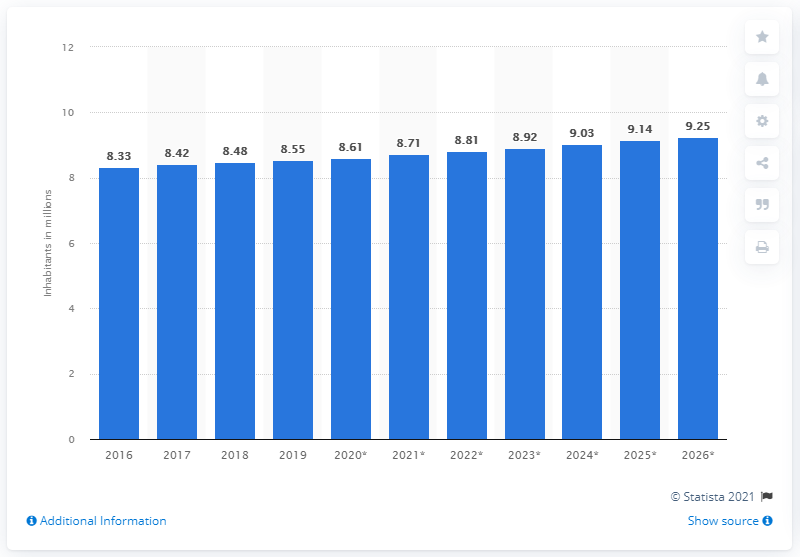Draw attention to some important aspects in this diagram. As of 2019, the population of Switzerland was 8.61 million. 